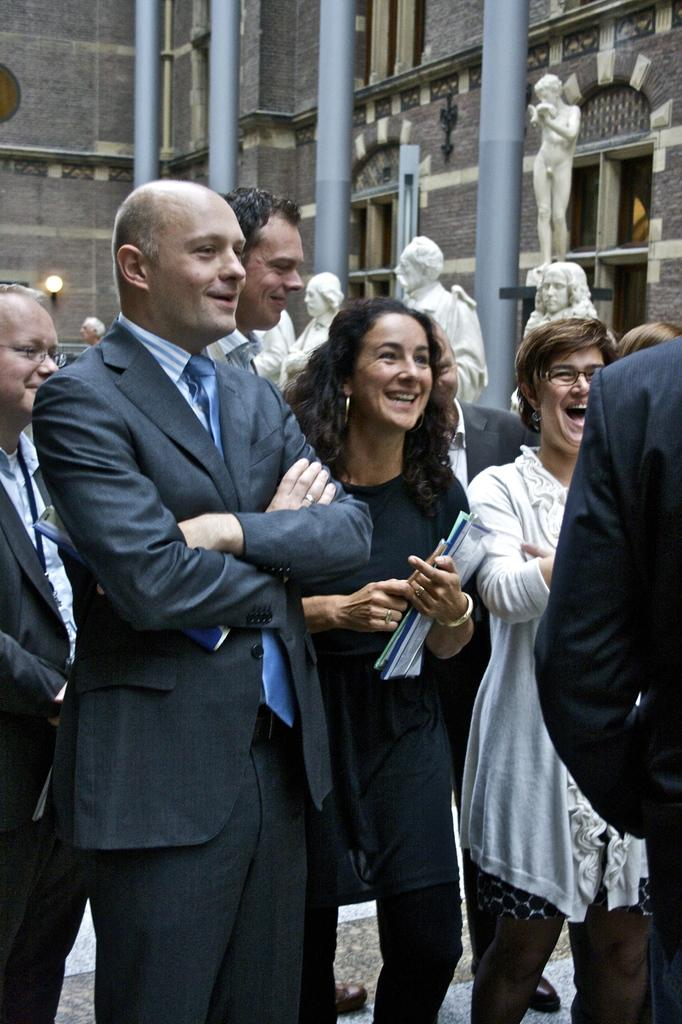What is happening in the center of the image? There are people in the center of the image. What are the people doing? The people are standing and smiling. What can be seen in the background of the image? There is a building, sculptures, and poles in the background of the image. What type of paint is being used by the people in the image? There is no paint or painting activity present in the image. How are the people transporting themselves in the image? The people are standing, and there is no indication of any transportation in the image. 